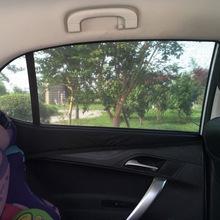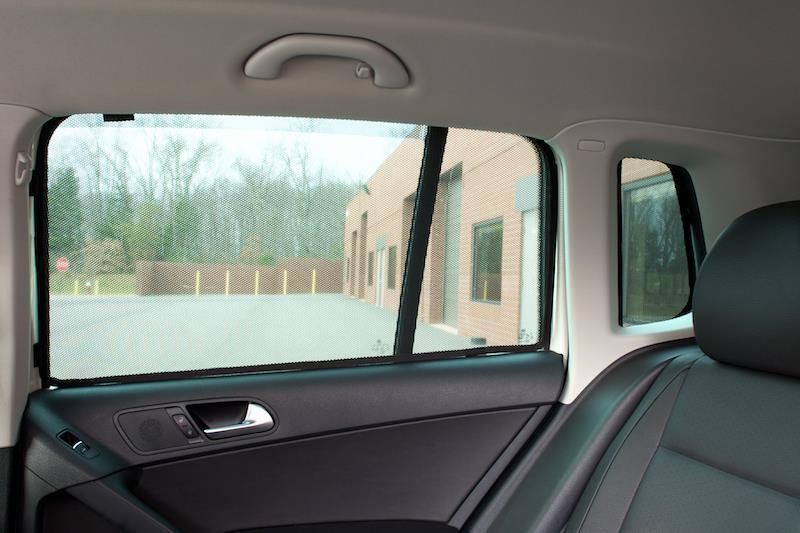The first image is the image on the left, the second image is the image on the right. Considering the images on both sides, is "An image shows a car window fitted with a squarish gray shade with nonrounded corners." valid? Answer yes or no. No. 